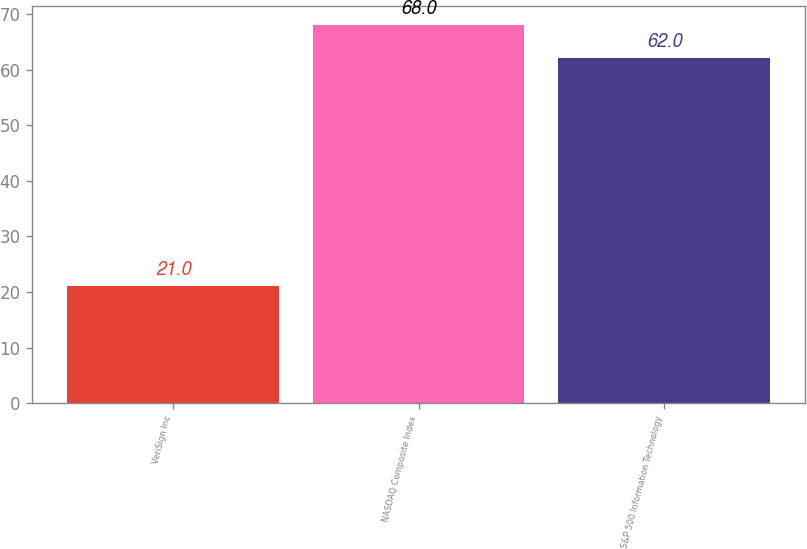Convert chart. <chart><loc_0><loc_0><loc_500><loc_500><bar_chart><fcel>VeriSign Inc<fcel>NASDAQ Composite Index<fcel>S&P 500 Information Technology<nl><fcel>21<fcel>68<fcel>62<nl></chart> 